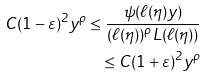Convert formula to latex. <formula><loc_0><loc_0><loc_500><loc_500>C ( 1 - \varepsilon ) ^ { 2 } y ^ { \rho } \leq \frac { \psi ( \ell ( \eta ) y ) } { ( \ell ( \eta ) ) ^ { \rho } L ( \ell ( \eta ) ) } \\ \leq C ( 1 + \varepsilon ) ^ { 2 } y ^ { \rho }</formula> 